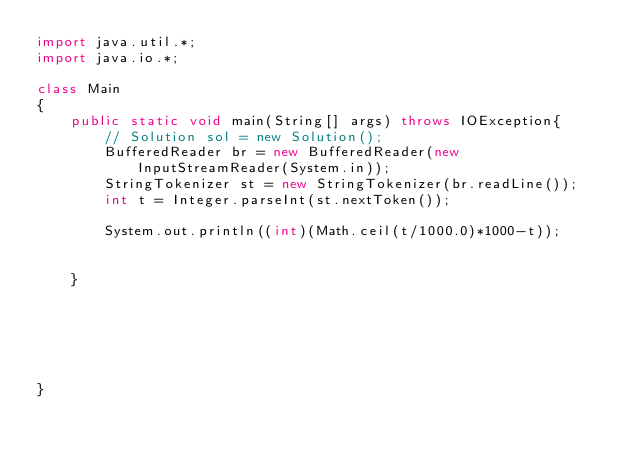<code> <loc_0><loc_0><loc_500><loc_500><_Java_>import java.util.*;
import java.io.*;

class Main
{
    public static void main(String[] args) throws IOException{
        // Solution sol = new Solution();
        BufferedReader br = new BufferedReader(new InputStreamReader(System.in));
        StringTokenizer st = new StringTokenizer(br.readLine());
        int t = Integer.parseInt(st.nextToken());
        
        System.out.println((int)(Math.ceil(t/1000.0)*1000-t));


    }

    


    

}</code> 